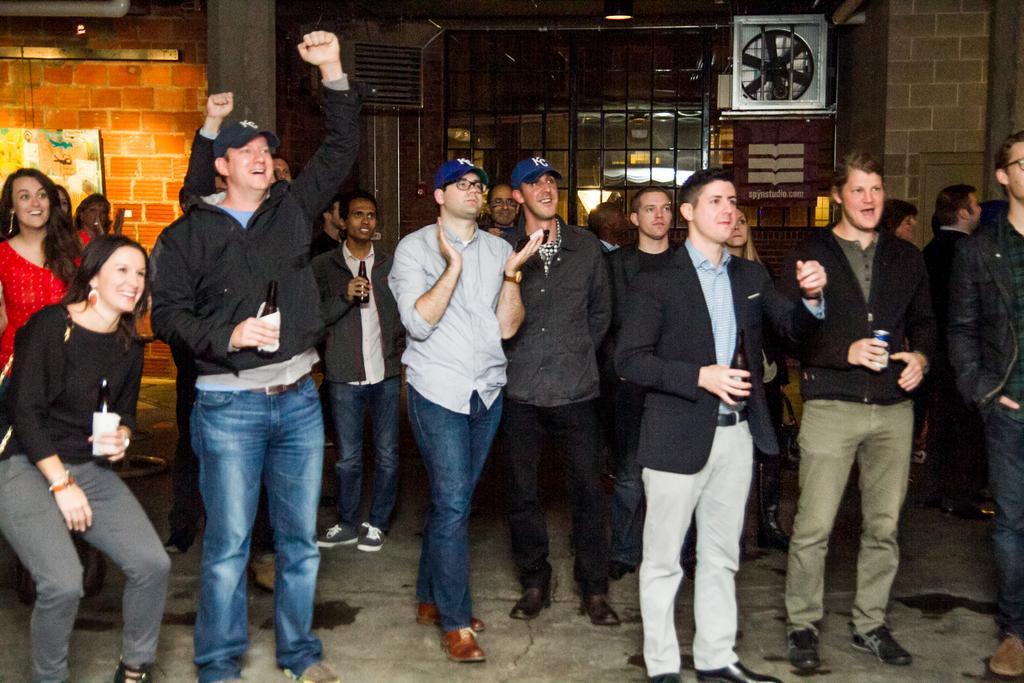Could you give a brief overview of what you see in this image? There are many people. Some are holding bottles, some are wearing caps, watches and specs. In the back there is a window, brick wall and there is an exhaust fan on the wall. Also there is a poster on the wall. 